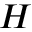Convert formula to latex. <formula><loc_0><loc_0><loc_500><loc_500>H</formula> 